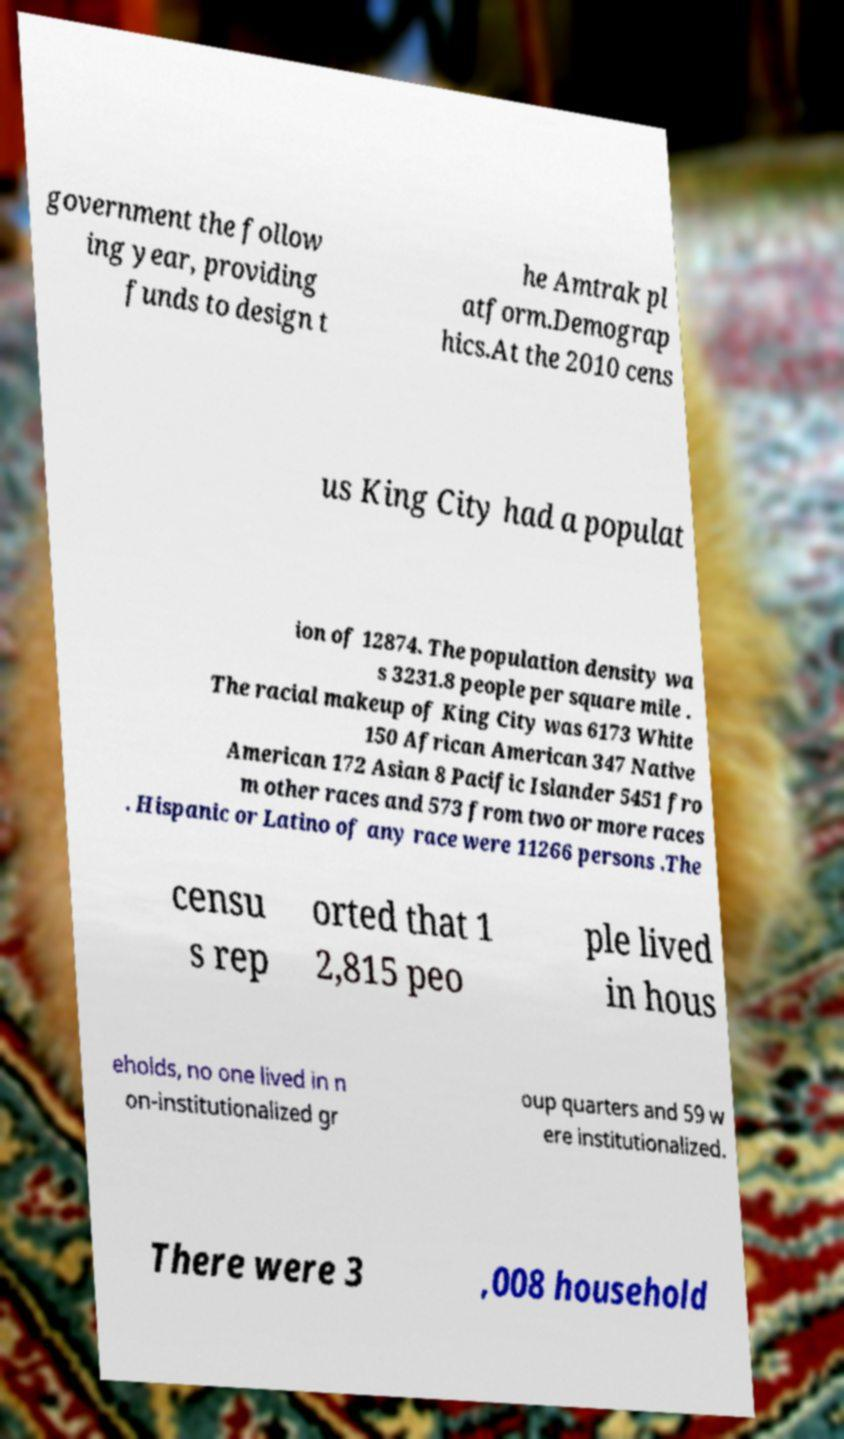Could you assist in decoding the text presented in this image and type it out clearly? government the follow ing year, providing funds to design t he Amtrak pl atform.Demograp hics.At the 2010 cens us King City had a populat ion of 12874. The population density wa s 3231.8 people per square mile . The racial makeup of King City was 6173 White 150 African American 347 Native American 172 Asian 8 Pacific Islander 5451 fro m other races and 573 from two or more races . Hispanic or Latino of any race were 11266 persons .The censu s rep orted that 1 2,815 peo ple lived in hous eholds, no one lived in n on-institutionalized gr oup quarters and 59 w ere institutionalized. There were 3 ,008 household 